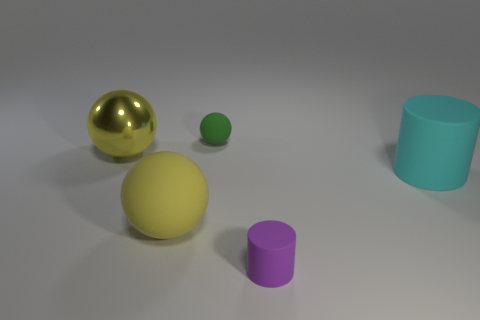What color is the big object that is both behind the yellow rubber object and right of the big metallic sphere?
Your answer should be compact. Cyan. What number of yellow rubber things are the same size as the yellow metallic thing?
Offer a terse response. 1. There is a ball that is both behind the big cyan cylinder and on the right side of the yellow shiny object; what is its size?
Provide a succinct answer. Small. How many yellow objects are on the left side of the purple rubber thing on the right side of the rubber object that is behind the large rubber cylinder?
Keep it short and to the point. 2. Is there a matte object of the same color as the shiny ball?
Provide a short and direct response. Yes. The rubber thing that is the same size as the green sphere is what color?
Keep it short and to the point. Purple. What shape is the big matte thing that is behind the rubber ball in front of the matte cylinder that is to the right of the purple cylinder?
Provide a short and direct response. Cylinder. What number of cylinders are in front of the large rubber thing that is right of the small purple matte cylinder?
Provide a succinct answer. 1. There is a small rubber object left of the small matte cylinder; does it have the same shape as the yellow thing in front of the yellow metallic ball?
Your response must be concise. Yes. There is a tiny green sphere; how many big balls are behind it?
Your answer should be compact. 0. 